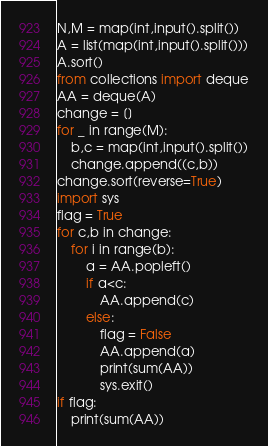Convert code to text. <code><loc_0><loc_0><loc_500><loc_500><_Python_>N,M = map(int,input().split())
A = list(map(int,input().split()))
A.sort()
from collections import deque
AA = deque(A)
change = []
for _ in range(M):
    b,c = map(int,input().split())
    change.append((c,b))
change.sort(reverse=True)
import sys
flag = True
for c,b in change:
    for i in range(b):
        a = AA.popleft()
        if a<c:
            AA.append(c)
        else:
            flag = False
            AA.append(a)
            print(sum(AA))
            sys.exit()
if flag:
    print(sum(AA))</code> 